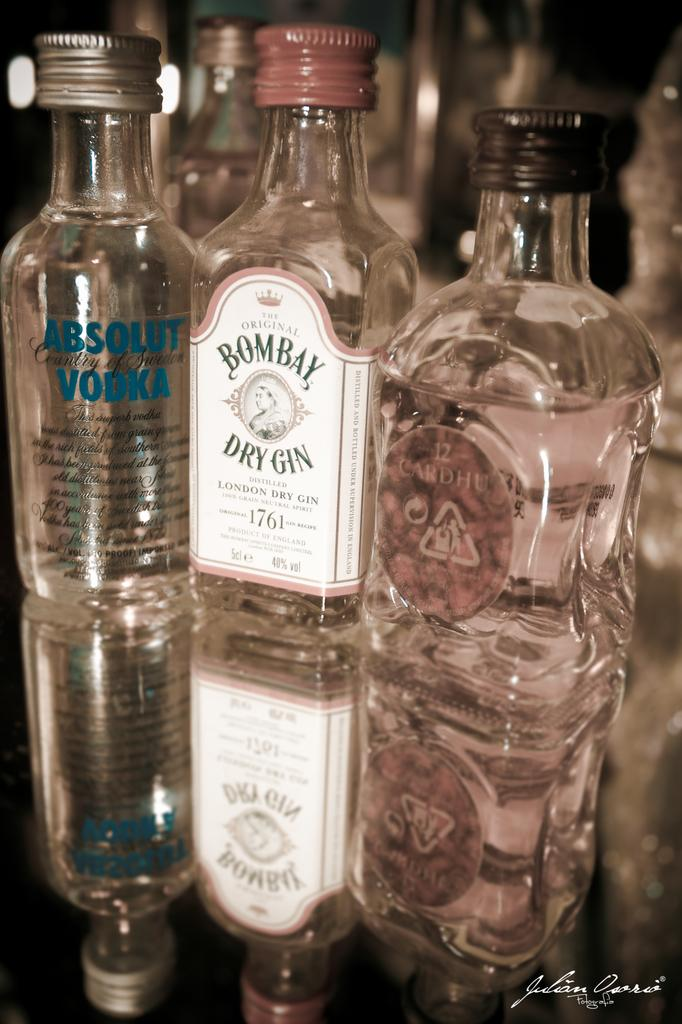Provide a one-sentence caption for the provided image. Three different alcohols featuring Bombay Dry Gin along with Absolut Vodka and Cardhe. 